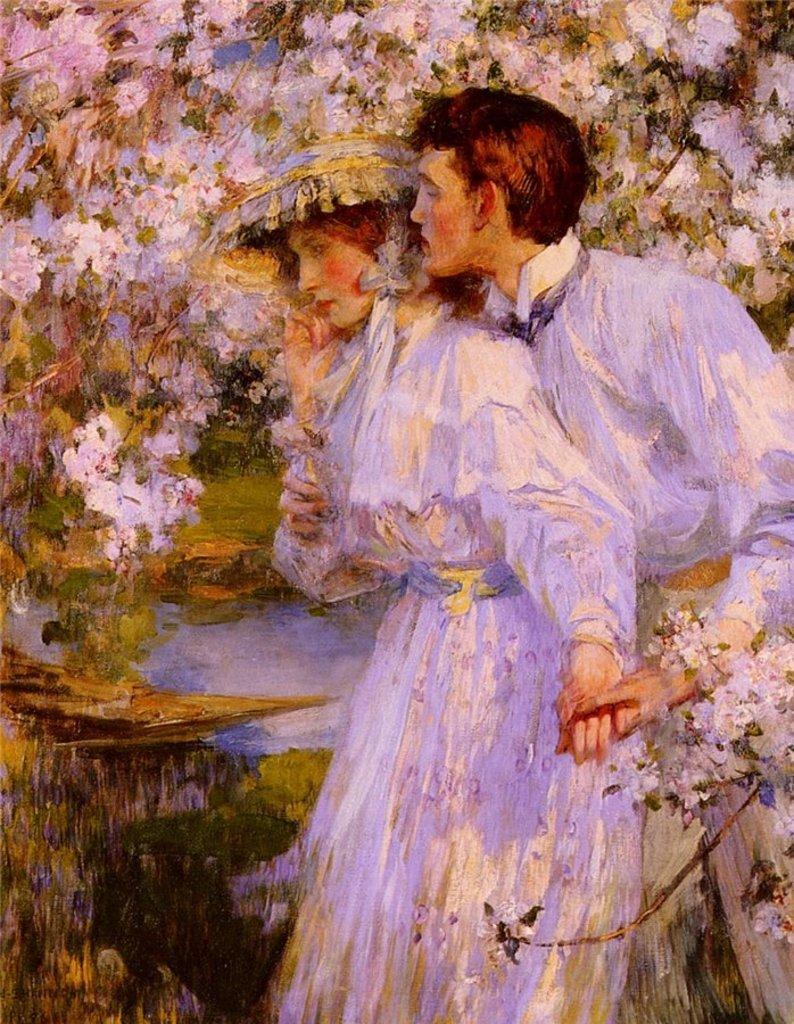How would you summarize this image in a sentence or two? In this image it is a painting in which there is a man standing behind the girl by holding her hand. The girl is having a cap. In the background there are flowers and trees. 